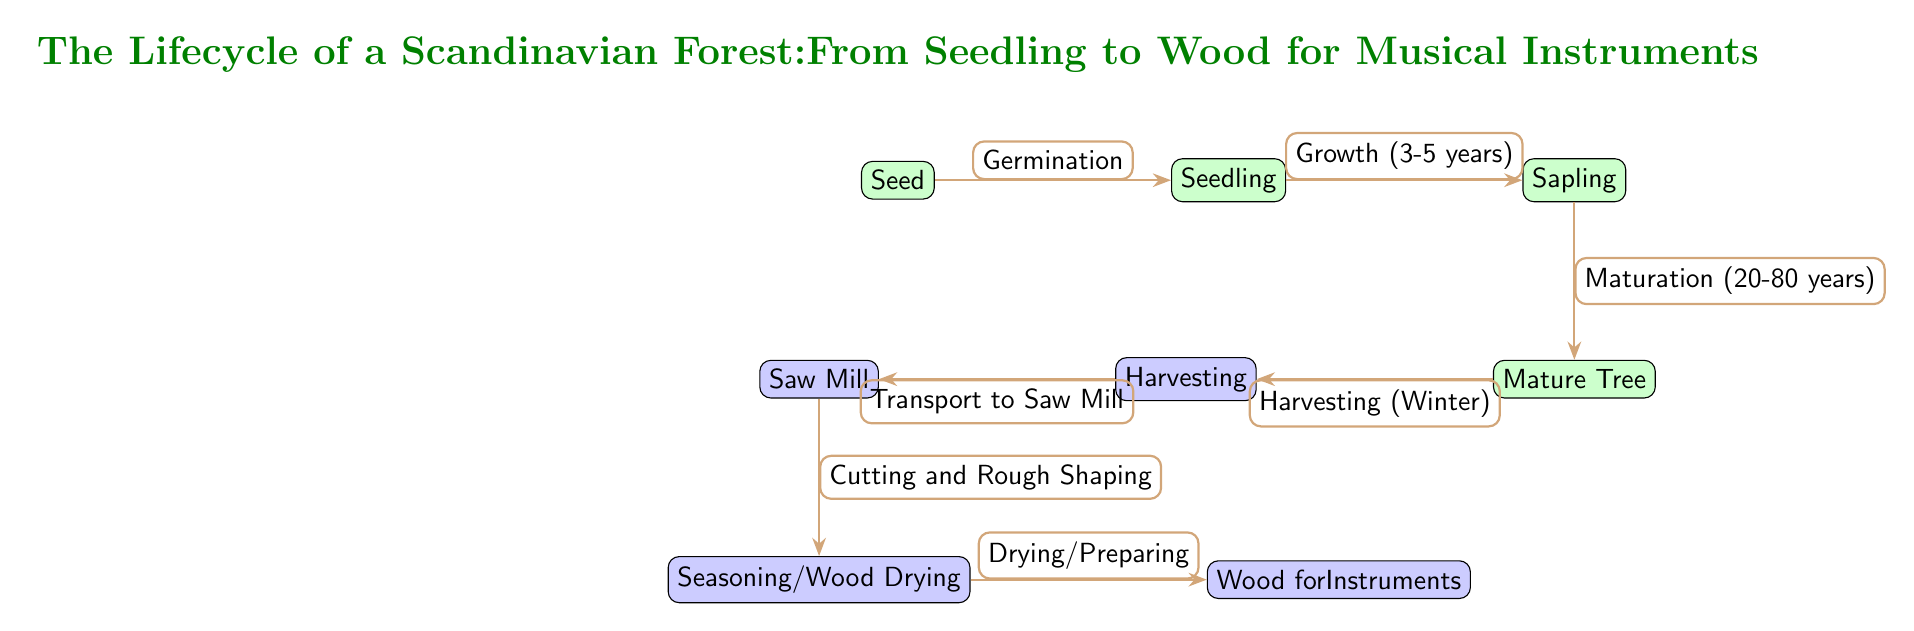What is the first stage in the lifecycle? The diagram starts with the "Seed" node, which is the first stage in the lifecycle of a Scandinavian forest.
Answer: Seed How many processes are there in the diagram? There are four process nodes in the diagram: Harvesting, Saw Mill, Seasoning/Wood Drying, and Wood for Instruments. Counting these directly from the diagram yields the answer.
Answer: 4 What is the expected growth period from Seedling to Sapling? The diagram indicates that the growth phase from Seedling to Sapling takes 3 to 5 years, which can be found by looking at the connecting arrow.
Answer: 3-5 years What happens after Harvesting? After Harvesting, the next step as indicated in the diagram is "Transport to Saw Mill," which shows the immediate phase that follows harvesting in the lifecycle.
Answer: Transport to Saw Mill What is the final output in the lifecycle? The final output in this lifecycle, as shown in the diagram, is "Wood for Instruments," completing the transition from Seed to usable wood.
Answer: Wood for Instruments During which season is harvesting typically done? According to the diagram, harvesting occurs in "Winter," which can be directly read from the labeling on the arrow leading from Mature Tree to Harvesting.
Answer: Winter What stage comes after Sapling? The diagram indicates that the stage following Sapling is "Mature Tree," which can be easily identified based on the direction of the arrows in the lifecycle sequence.
Answer: Mature Tree How many total nodes are shown in the diagram? By counting both the forest nodes and the process nodes in the diagram, there are a total of seven nodes (3 forest nodes, 4 process nodes).
Answer: 7 